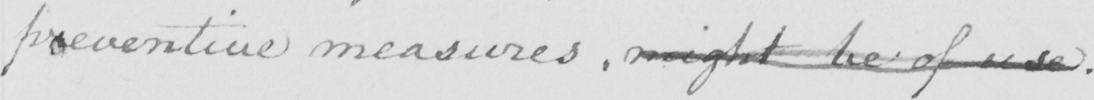Please transcribe the handwritten text in this image. preventive measures. might be of use. 